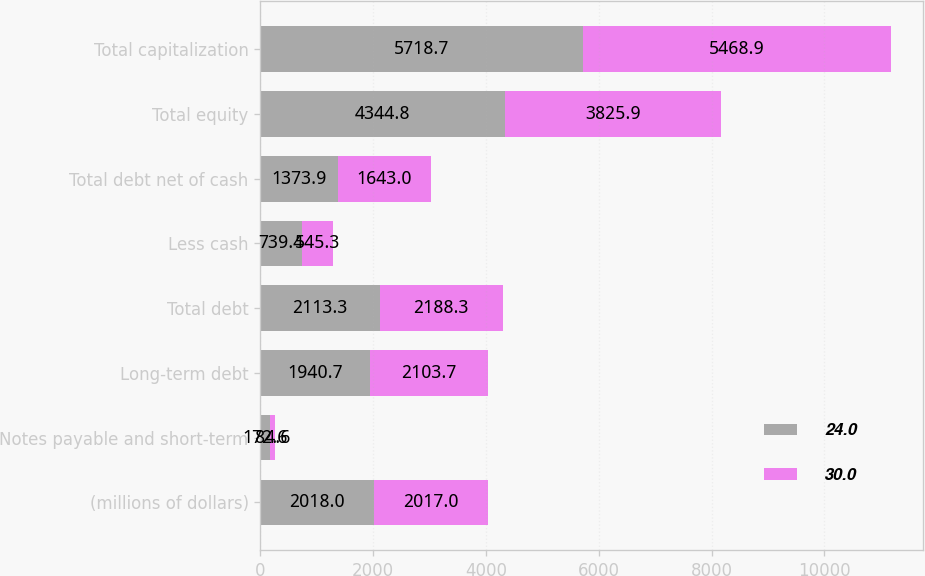<chart> <loc_0><loc_0><loc_500><loc_500><stacked_bar_chart><ecel><fcel>(millions of dollars)<fcel>Notes payable and short-term<fcel>Long-term debt<fcel>Total debt<fcel>Less cash<fcel>Total debt net of cash<fcel>Total equity<fcel>Total capitalization<nl><fcel>24<fcel>2018<fcel>172.6<fcel>1940.7<fcel>2113.3<fcel>739.4<fcel>1373.9<fcel>4344.8<fcel>5718.7<nl><fcel>30<fcel>2017<fcel>84.6<fcel>2103.7<fcel>2188.3<fcel>545.3<fcel>1643<fcel>3825.9<fcel>5468.9<nl></chart> 